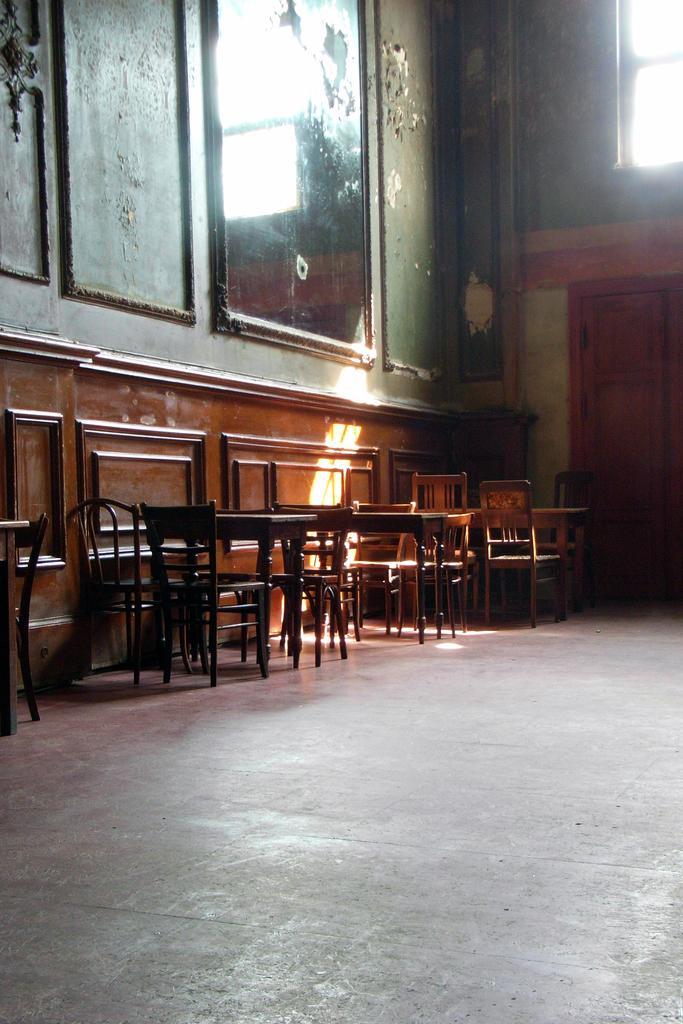Could you give a brief overview of what you see in this image? In this image I can see the inner part of the building. I can see few chairs,tables,door,window,few frames attached to the wall. 